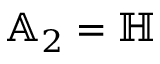Convert formula to latex. <formula><loc_0><loc_0><loc_500><loc_500>\mathbb { A } _ { 2 } = \mathbb { H }</formula> 